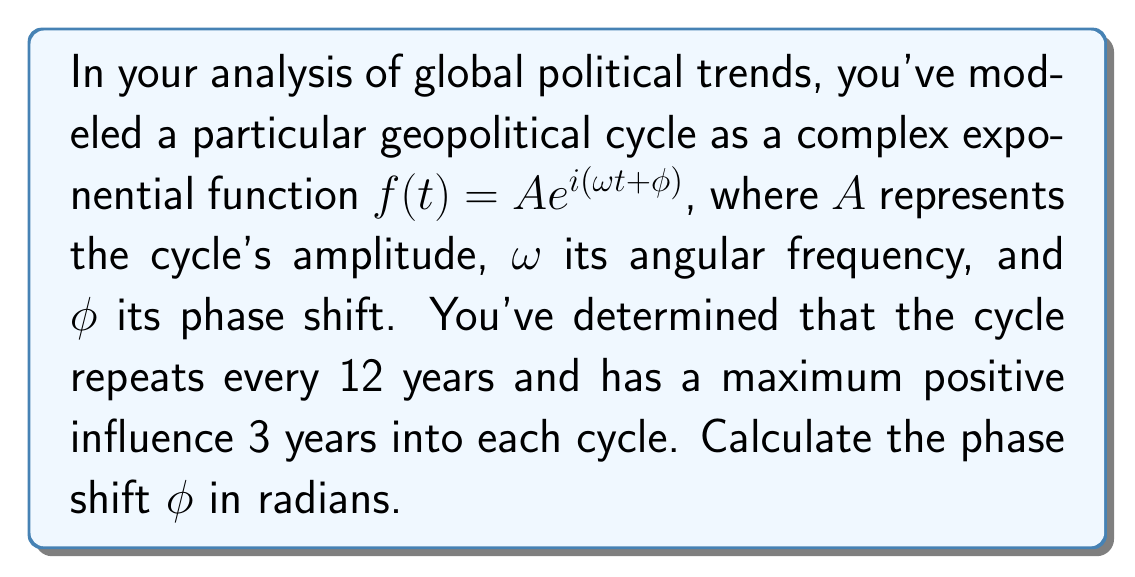Can you solve this math problem? Let's approach this step-by-step:

1) The period of the cycle is 12 years. For a complex exponential function, the period $T$ is related to the angular frequency $\omega$ by:

   $$T = \frac{2\pi}{\omega}$$

2) Solving for $\omega$:

   $$\omega = \frac{2\pi}{T} = \frac{2\pi}{12} = \frac{\pi}{6}$$

3) The maximum positive influence occurs when the real part of the complex exponential is at its maximum, which happens when:

   $$\omega t + \phi = 0$$

4) We know this occurs 3 years into the cycle, so:

   $$\frac{\pi}{6} \cdot 3 + \phi = 0$$

5) Solving for $\phi$:

   $$\phi = -\frac{\pi}{6} \cdot 3 = -\frac{\pi}{2}$$

6) Therefore, the phase shift is $-\frac{\pi}{2}$ radians.
Answer: $-\frac{\pi}{2}$ radians 